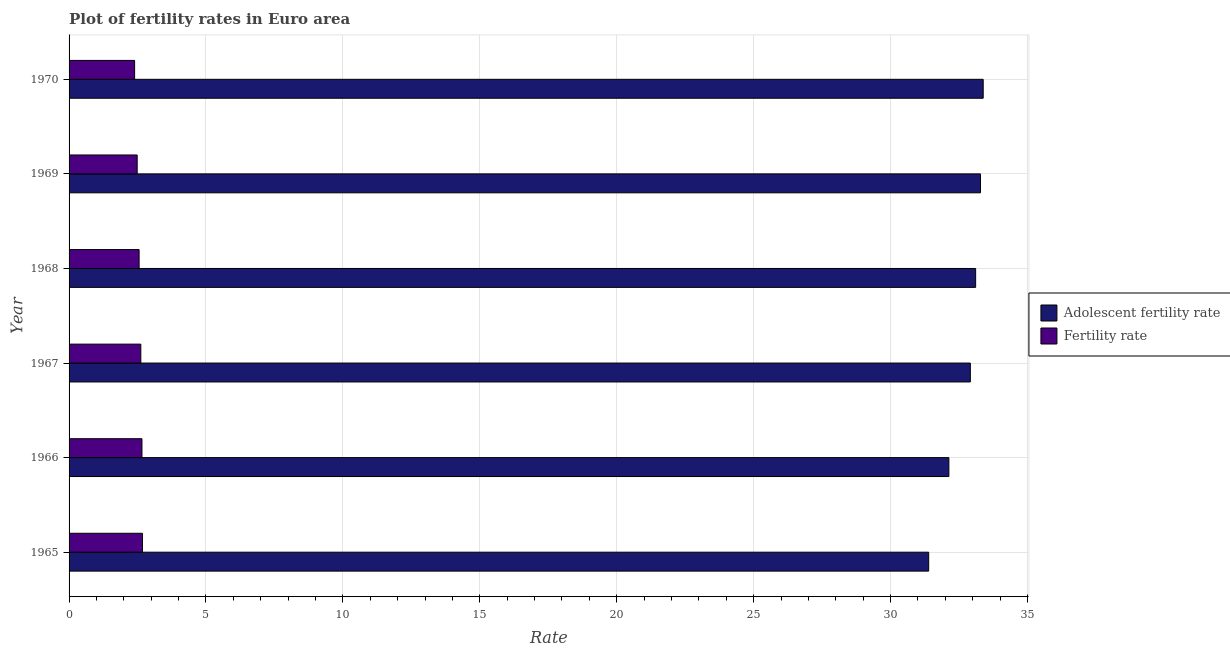How many groups of bars are there?
Provide a succinct answer. 6. Are the number of bars per tick equal to the number of legend labels?
Keep it short and to the point. Yes. In how many cases, is the number of bars for a given year not equal to the number of legend labels?
Make the answer very short. 0. What is the adolescent fertility rate in 1970?
Offer a terse response. 33.38. Across all years, what is the maximum fertility rate?
Ensure brevity in your answer.  2.68. Across all years, what is the minimum fertility rate?
Provide a short and direct response. 2.39. What is the total adolescent fertility rate in the graph?
Provide a succinct answer. 196.2. What is the difference between the adolescent fertility rate in 1968 and that in 1970?
Offer a terse response. -0.28. What is the difference between the fertility rate in 1966 and the adolescent fertility rate in 1968?
Offer a very short reply. -30.44. What is the average adolescent fertility rate per year?
Make the answer very short. 32.7. In the year 1966, what is the difference between the adolescent fertility rate and fertility rate?
Offer a very short reply. 29.47. In how many years, is the adolescent fertility rate greater than 27 ?
Make the answer very short. 6. What is the ratio of the adolescent fertility rate in 1967 to that in 1969?
Offer a very short reply. 0.99. Is the fertility rate in 1965 less than that in 1966?
Your answer should be very brief. No. Is the difference between the adolescent fertility rate in 1966 and 1968 greater than the difference between the fertility rate in 1966 and 1968?
Give a very brief answer. No. What is the difference between the highest and the second highest fertility rate?
Your answer should be very brief. 0.02. What is the difference between the highest and the lowest adolescent fertility rate?
Your answer should be very brief. 1.99. What does the 1st bar from the top in 1969 represents?
Your response must be concise. Fertility rate. What does the 1st bar from the bottom in 1966 represents?
Make the answer very short. Adolescent fertility rate. How many bars are there?
Provide a succinct answer. 12. How many years are there in the graph?
Provide a succinct answer. 6. What is the difference between two consecutive major ticks on the X-axis?
Your answer should be compact. 5. Are the values on the major ticks of X-axis written in scientific E-notation?
Make the answer very short. No. Does the graph contain grids?
Keep it short and to the point. Yes. Where does the legend appear in the graph?
Give a very brief answer. Center right. What is the title of the graph?
Ensure brevity in your answer.  Plot of fertility rates in Euro area. Does "Grants" appear as one of the legend labels in the graph?
Ensure brevity in your answer.  No. What is the label or title of the X-axis?
Your answer should be very brief. Rate. What is the label or title of the Y-axis?
Offer a terse response. Year. What is the Rate in Adolescent fertility rate in 1965?
Offer a very short reply. 31.39. What is the Rate in Fertility rate in 1965?
Make the answer very short. 2.68. What is the Rate of Adolescent fertility rate in 1966?
Provide a succinct answer. 32.13. What is the Rate of Fertility rate in 1966?
Offer a terse response. 2.66. What is the Rate of Adolescent fertility rate in 1967?
Ensure brevity in your answer.  32.91. What is the Rate in Fertility rate in 1967?
Offer a very short reply. 2.62. What is the Rate of Adolescent fertility rate in 1968?
Your response must be concise. 33.11. What is the Rate in Fertility rate in 1968?
Give a very brief answer. 2.56. What is the Rate in Adolescent fertility rate in 1969?
Provide a succinct answer. 33.28. What is the Rate of Fertility rate in 1969?
Ensure brevity in your answer.  2.49. What is the Rate of Adolescent fertility rate in 1970?
Provide a succinct answer. 33.38. What is the Rate in Fertility rate in 1970?
Provide a succinct answer. 2.39. Across all years, what is the maximum Rate in Adolescent fertility rate?
Keep it short and to the point. 33.38. Across all years, what is the maximum Rate in Fertility rate?
Ensure brevity in your answer.  2.68. Across all years, what is the minimum Rate in Adolescent fertility rate?
Provide a short and direct response. 31.39. Across all years, what is the minimum Rate in Fertility rate?
Offer a terse response. 2.39. What is the total Rate of Adolescent fertility rate in the graph?
Your answer should be very brief. 196.2. What is the total Rate of Fertility rate in the graph?
Provide a succinct answer. 15.4. What is the difference between the Rate in Adolescent fertility rate in 1965 and that in 1966?
Keep it short and to the point. -0.74. What is the difference between the Rate of Fertility rate in 1965 and that in 1966?
Make the answer very short. 0.02. What is the difference between the Rate in Adolescent fertility rate in 1965 and that in 1967?
Your answer should be very brief. -1.52. What is the difference between the Rate of Fertility rate in 1965 and that in 1967?
Provide a succinct answer. 0.06. What is the difference between the Rate of Adolescent fertility rate in 1965 and that in 1968?
Offer a very short reply. -1.71. What is the difference between the Rate of Fertility rate in 1965 and that in 1968?
Your response must be concise. 0.12. What is the difference between the Rate of Adolescent fertility rate in 1965 and that in 1969?
Offer a terse response. -1.89. What is the difference between the Rate in Fertility rate in 1965 and that in 1969?
Provide a short and direct response. 0.19. What is the difference between the Rate in Adolescent fertility rate in 1965 and that in 1970?
Provide a short and direct response. -1.99. What is the difference between the Rate of Fertility rate in 1965 and that in 1970?
Offer a terse response. 0.29. What is the difference between the Rate in Adolescent fertility rate in 1966 and that in 1967?
Provide a succinct answer. -0.78. What is the difference between the Rate in Fertility rate in 1966 and that in 1967?
Your answer should be compact. 0.04. What is the difference between the Rate of Adolescent fertility rate in 1966 and that in 1968?
Keep it short and to the point. -0.98. What is the difference between the Rate in Fertility rate in 1966 and that in 1968?
Make the answer very short. 0.1. What is the difference between the Rate of Adolescent fertility rate in 1966 and that in 1969?
Offer a terse response. -1.15. What is the difference between the Rate in Fertility rate in 1966 and that in 1969?
Provide a short and direct response. 0.17. What is the difference between the Rate of Adolescent fertility rate in 1966 and that in 1970?
Offer a terse response. -1.25. What is the difference between the Rate of Fertility rate in 1966 and that in 1970?
Provide a short and direct response. 0.27. What is the difference between the Rate of Adolescent fertility rate in 1967 and that in 1968?
Your response must be concise. -0.19. What is the difference between the Rate of Fertility rate in 1967 and that in 1968?
Provide a short and direct response. 0.06. What is the difference between the Rate of Adolescent fertility rate in 1967 and that in 1969?
Give a very brief answer. -0.37. What is the difference between the Rate in Fertility rate in 1967 and that in 1969?
Keep it short and to the point. 0.13. What is the difference between the Rate in Adolescent fertility rate in 1967 and that in 1970?
Make the answer very short. -0.47. What is the difference between the Rate of Fertility rate in 1967 and that in 1970?
Your answer should be compact. 0.23. What is the difference between the Rate in Adolescent fertility rate in 1968 and that in 1969?
Ensure brevity in your answer.  -0.18. What is the difference between the Rate of Fertility rate in 1968 and that in 1969?
Keep it short and to the point. 0.07. What is the difference between the Rate of Adolescent fertility rate in 1968 and that in 1970?
Keep it short and to the point. -0.28. What is the difference between the Rate of Fertility rate in 1968 and that in 1970?
Provide a short and direct response. 0.16. What is the difference between the Rate of Adolescent fertility rate in 1969 and that in 1970?
Offer a terse response. -0.1. What is the difference between the Rate of Fertility rate in 1969 and that in 1970?
Offer a terse response. 0.09. What is the difference between the Rate in Adolescent fertility rate in 1965 and the Rate in Fertility rate in 1966?
Your answer should be very brief. 28.73. What is the difference between the Rate in Adolescent fertility rate in 1965 and the Rate in Fertility rate in 1967?
Your answer should be very brief. 28.77. What is the difference between the Rate in Adolescent fertility rate in 1965 and the Rate in Fertility rate in 1968?
Offer a very short reply. 28.83. What is the difference between the Rate in Adolescent fertility rate in 1965 and the Rate in Fertility rate in 1969?
Provide a short and direct response. 28.9. What is the difference between the Rate in Adolescent fertility rate in 1965 and the Rate in Fertility rate in 1970?
Offer a terse response. 29. What is the difference between the Rate in Adolescent fertility rate in 1966 and the Rate in Fertility rate in 1967?
Provide a succinct answer. 29.51. What is the difference between the Rate of Adolescent fertility rate in 1966 and the Rate of Fertility rate in 1968?
Make the answer very short. 29.57. What is the difference between the Rate in Adolescent fertility rate in 1966 and the Rate in Fertility rate in 1969?
Offer a very short reply. 29.64. What is the difference between the Rate of Adolescent fertility rate in 1966 and the Rate of Fertility rate in 1970?
Offer a terse response. 29.74. What is the difference between the Rate in Adolescent fertility rate in 1967 and the Rate in Fertility rate in 1968?
Offer a very short reply. 30.36. What is the difference between the Rate in Adolescent fertility rate in 1967 and the Rate in Fertility rate in 1969?
Your response must be concise. 30.43. What is the difference between the Rate in Adolescent fertility rate in 1967 and the Rate in Fertility rate in 1970?
Ensure brevity in your answer.  30.52. What is the difference between the Rate of Adolescent fertility rate in 1968 and the Rate of Fertility rate in 1969?
Ensure brevity in your answer.  30.62. What is the difference between the Rate of Adolescent fertility rate in 1968 and the Rate of Fertility rate in 1970?
Provide a short and direct response. 30.71. What is the difference between the Rate in Adolescent fertility rate in 1969 and the Rate in Fertility rate in 1970?
Keep it short and to the point. 30.89. What is the average Rate of Adolescent fertility rate per year?
Make the answer very short. 32.7. What is the average Rate in Fertility rate per year?
Ensure brevity in your answer.  2.57. In the year 1965, what is the difference between the Rate of Adolescent fertility rate and Rate of Fertility rate?
Provide a short and direct response. 28.71. In the year 1966, what is the difference between the Rate of Adolescent fertility rate and Rate of Fertility rate?
Your answer should be compact. 29.47. In the year 1967, what is the difference between the Rate of Adolescent fertility rate and Rate of Fertility rate?
Your answer should be compact. 30.29. In the year 1968, what is the difference between the Rate in Adolescent fertility rate and Rate in Fertility rate?
Offer a very short reply. 30.55. In the year 1969, what is the difference between the Rate of Adolescent fertility rate and Rate of Fertility rate?
Make the answer very short. 30.8. In the year 1970, what is the difference between the Rate in Adolescent fertility rate and Rate in Fertility rate?
Your response must be concise. 30.99. What is the ratio of the Rate in Adolescent fertility rate in 1965 to that in 1966?
Your answer should be very brief. 0.98. What is the ratio of the Rate in Adolescent fertility rate in 1965 to that in 1967?
Your answer should be very brief. 0.95. What is the ratio of the Rate of Fertility rate in 1965 to that in 1967?
Make the answer very short. 1.02. What is the ratio of the Rate of Adolescent fertility rate in 1965 to that in 1968?
Your response must be concise. 0.95. What is the ratio of the Rate in Fertility rate in 1965 to that in 1968?
Provide a short and direct response. 1.05. What is the ratio of the Rate in Adolescent fertility rate in 1965 to that in 1969?
Your response must be concise. 0.94. What is the ratio of the Rate in Fertility rate in 1965 to that in 1969?
Ensure brevity in your answer.  1.08. What is the ratio of the Rate in Adolescent fertility rate in 1965 to that in 1970?
Your response must be concise. 0.94. What is the ratio of the Rate of Fertility rate in 1965 to that in 1970?
Offer a terse response. 1.12. What is the ratio of the Rate in Adolescent fertility rate in 1966 to that in 1967?
Offer a very short reply. 0.98. What is the ratio of the Rate of Fertility rate in 1966 to that in 1967?
Keep it short and to the point. 1.02. What is the ratio of the Rate of Adolescent fertility rate in 1966 to that in 1968?
Your answer should be compact. 0.97. What is the ratio of the Rate of Fertility rate in 1966 to that in 1968?
Your answer should be compact. 1.04. What is the ratio of the Rate of Adolescent fertility rate in 1966 to that in 1969?
Your answer should be compact. 0.97. What is the ratio of the Rate of Fertility rate in 1966 to that in 1969?
Your answer should be very brief. 1.07. What is the ratio of the Rate of Adolescent fertility rate in 1966 to that in 1970?
Your answer should be compact. 0.96. What is the ratio of the Rate in Fertility rate in 1966 to that in 1970?
Your answer should be compact. 1.11. What is the ratio of the Rate of Fertility rate in 1967 to that in 1968?
Your response must be concise. 1.02. What is the ratio of the Rate of Adolescent fertility rate in 1967 to that in 1969?
Give a very brief answer. 0.99. What is the ratio of the Rate of Fertility rate in 1967 to that in 1969?
Offer a terse response. 1.05. What is the ratio of the Rate of Adolescent fertility rate in 1967 to that in 1970?
Keep it short and to the point. 0.99. What is the ratio of the Rate of Fertility rate in 1967 to that in 1970?
Your response must be concise. 1.09. What is the ratio of the Rate of Fertility rate in 1968 to that in 1969?
Ensure brevity in your answer.  1.03. What is the ratio of the Rate in Fertility rate in 1968 to that in 1970?
Provide a succinct answer. 1.07. What is the ratio of the Rate of Fertility rate in 1969 to that in 1970?
Ensure brevity in your answer.  1.04. What is the difference between the highest and the second highest Rate of Adolescent fertility rate?
Keep it short and to the point. 0.1. What is the difference between the highest and the second highest Rate of Fertility rate?
Your answer should be compact. 0.02. What is the difference between the highest and the lowest Rate of Adolescent fertility rate?
Provide a short and direct response. 1.99. What is the difference between the highest and the lowest Rate in Fertility rate?
Offer a terse response. 0.29. 